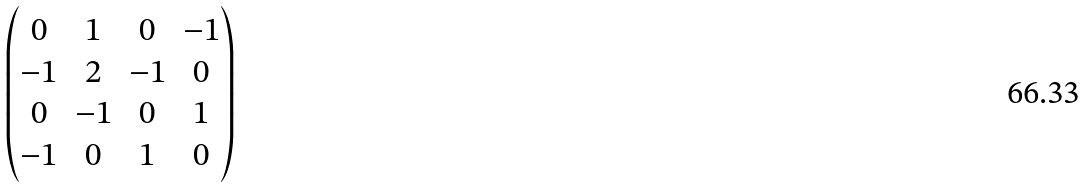Convert formula to latex. <formula><loc_0><loc_0><loc_500><loc_500>\begin{pmatrix} 0 & 1 & 0 & - 1 \\ - 1 & 2 & - 1 & 0 \\ 0 & - 1 & 0 & 1 \\ - 1 & 0 & 1 & 0 \end{pmatrix}</formula> 